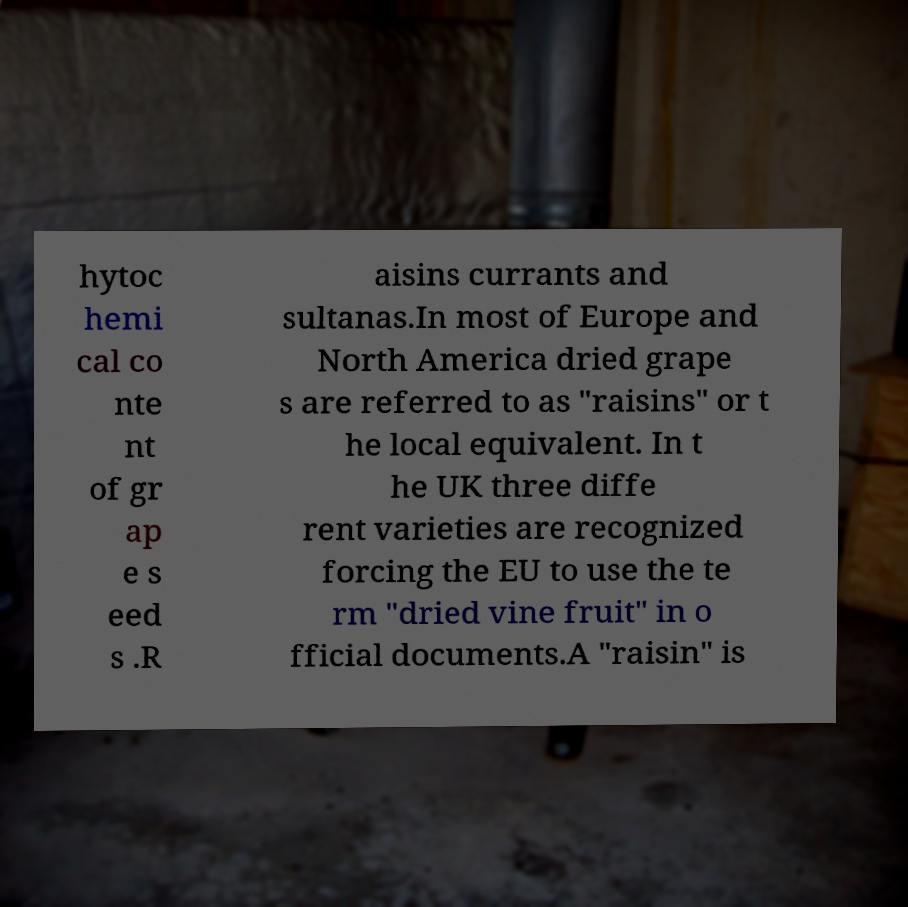Can you accurately transcribe the text from the provided image for me? hytoc hemi cal co nte nt of gr ap e s eed s .R aisins currants and sultanas.In most of Europe and North America dried grape s are referred to as "raisins" or t he local equivalent. In t he UK three diffe rent varieties are recognized forcing the EU to use the te rm "dried vine fruit" in o fficial documents.A "raisin" is 